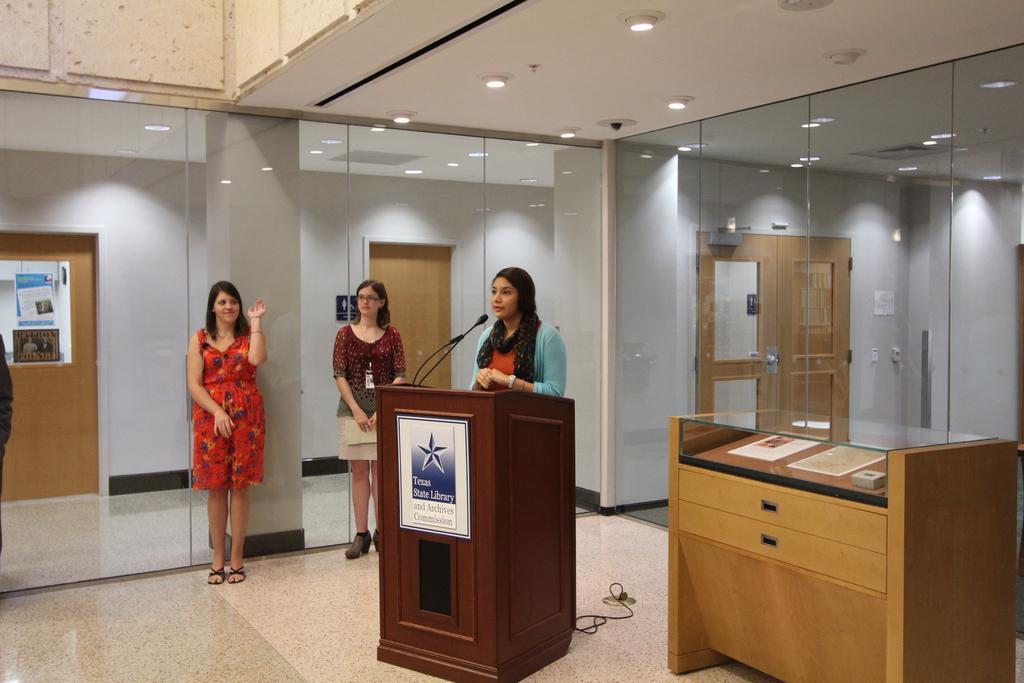Please provide a concise description of this image. In this picture I can observe three women. One of them is standing in front of a podium. There are some glasses. In the background I can observe brown color doors and a wall. 